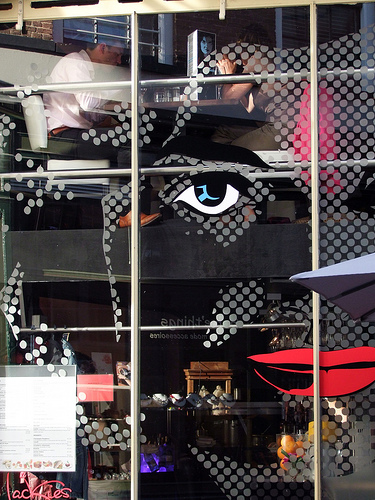<image>
Is the picture under the man? Yes. The picture is positioned underneath the man, with the man above it in the vertical space. 